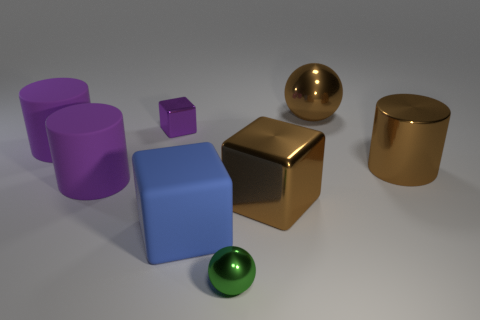Add 2 large brown metallic balls. How many objects exist? 10 Subtract all spheres. How many objects are left? 6 Add 7 big purple things. How many big purple things are left? 9 Add 6 purple rubber objects. How many purple rubber objects exist? 8 Subtract 0 blue spheres. How many objects are left? 8 Subtract all big brown shiny blocks. Subtract all big purple matte spheres. How many objects are left? 7 